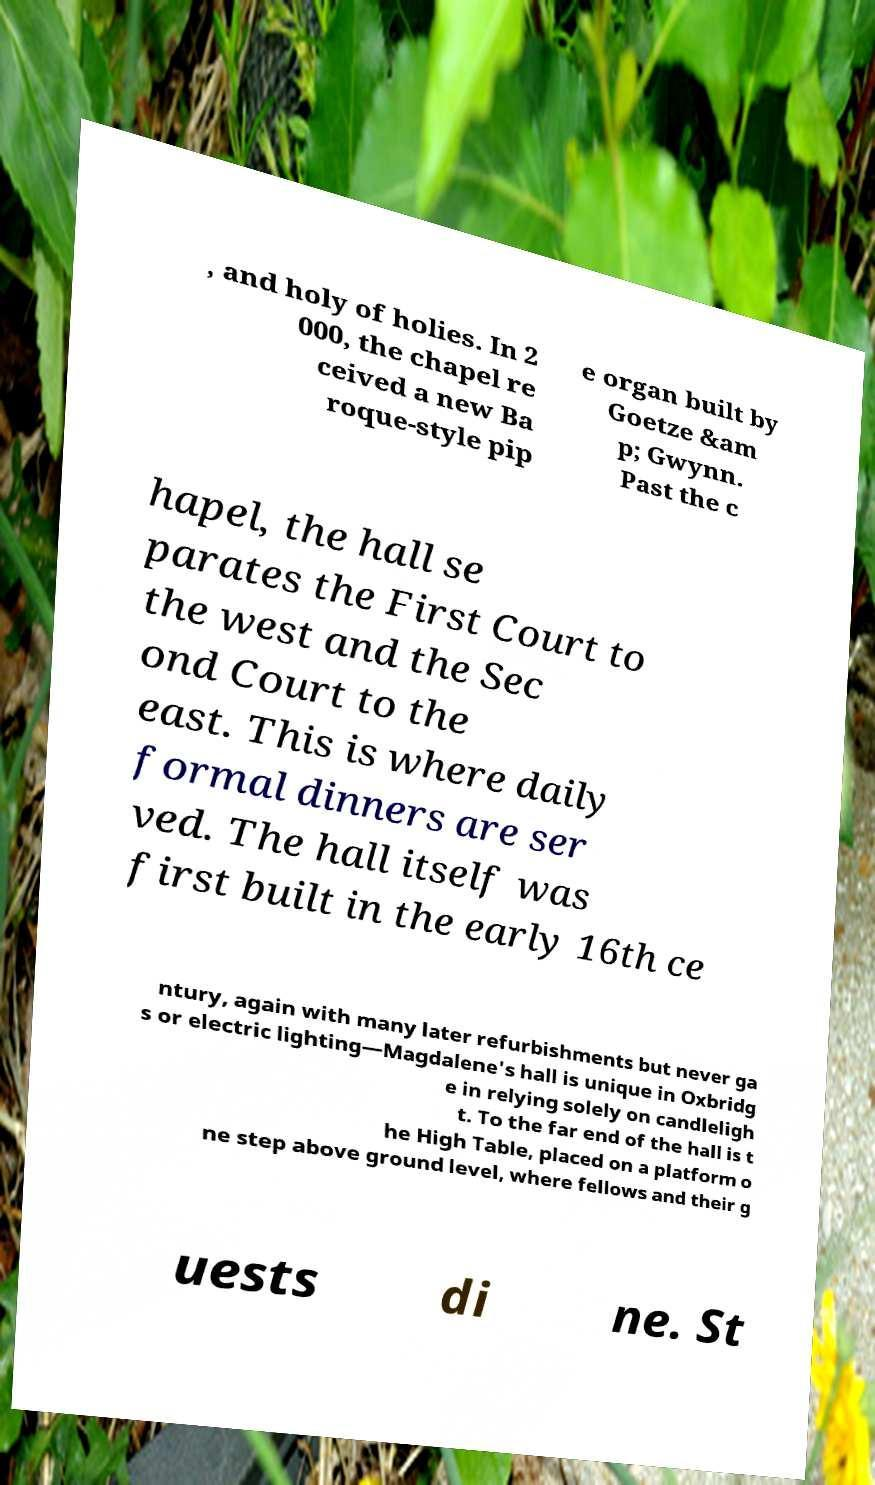Could you assist in decoding the text presented in this image and type it out clearly? , and holy of holies. In 2 000, the chapel re ceived a new Ba roque-style pip e organ built by Goetze &am p; Gwynn. Past the c hapel, the hall se parates the First Court to the west and the Sec ond Court to the east. This is where daily formal dinners are ser ved. The hall itself was first built in the early 16th ce ntury, again with many later refurbishments but never ga s or electric lighting—Magdalene's hall is unique in Oxbridg e in relying solely on candleligh t. To the far end of the hall is t he High Table, placed on a platform o ne step above ground level, where fellows and their g uests di ne. St 